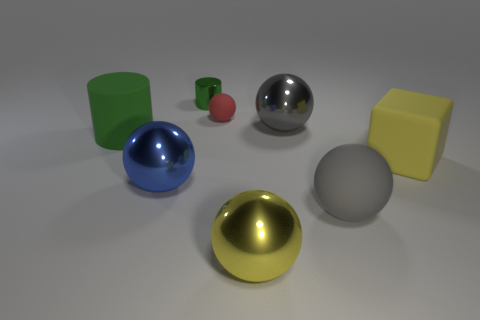What can you tell me about the lighting and shadows in the scene? The lighting in the scene is coming from an overhead source, creating soft shadows beneath each object. The shadows are diffuse and suggest that the light source is not extremely close to the objects, providing even illumination across the scene. 